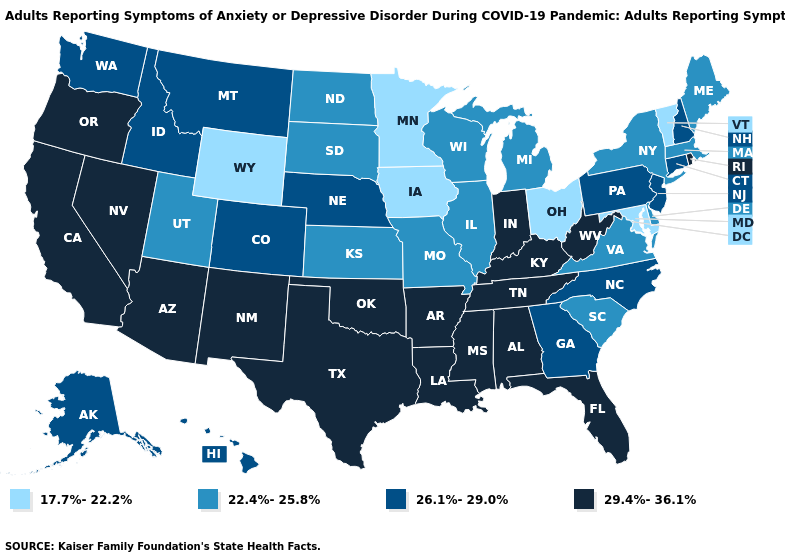Among the states that border Nevada , does Idaho have the lowest value?
Be succinct. No. What is the highest value in the West ?
Write a very short answer. 29.4%-36.1%. Is the legend a continuous bar?
Concise answer only. No. Does the map have missing data?
Be succinct. No. What is the value of Nevada?
Concise answer only. 29.4%-36.1%. Among the states that border Alabama , does Georgia have the lowest value?
Answer briefly. Yes. Does the first symbol in the legend represent the smallest category?
Be succinct. Yes. What is the value of New York?
Keep it brief. 22.4%-25.8%. What is the value of Iowa?
Answer briefly. 17.7%-22.2%. Among the states that border South Dakota , which have the lowest value?
Answer briefly. Iowa, Minnesota, Wyoming. What is the highest value in the West ?
Answer briefly. 29.4%-36.1%. What is the lowest value in the MidWest?
Answer briefly. 17.7%-22.2%. Does Mississippi have the same value as New Mexico?
Concise answer only. Yes. Does Ohio have the lowest value in the USA?
Concise answer only. Yes. What is the value of Missouri?
Quick response, please. 22.4%-25.8%. 